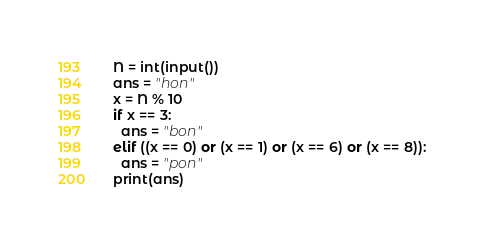Convert code to text. <code><loc_0><loc_0><loc_500><loc_500><_Python_>N = int(input())
ans = "hon"
x = N % 10
if x == 3:
  ans = "bon"
elif ((x == 0) or (x == 1) or (x == 6) or (x == 8)):
  ans = "pon"
print(ans)</code> 